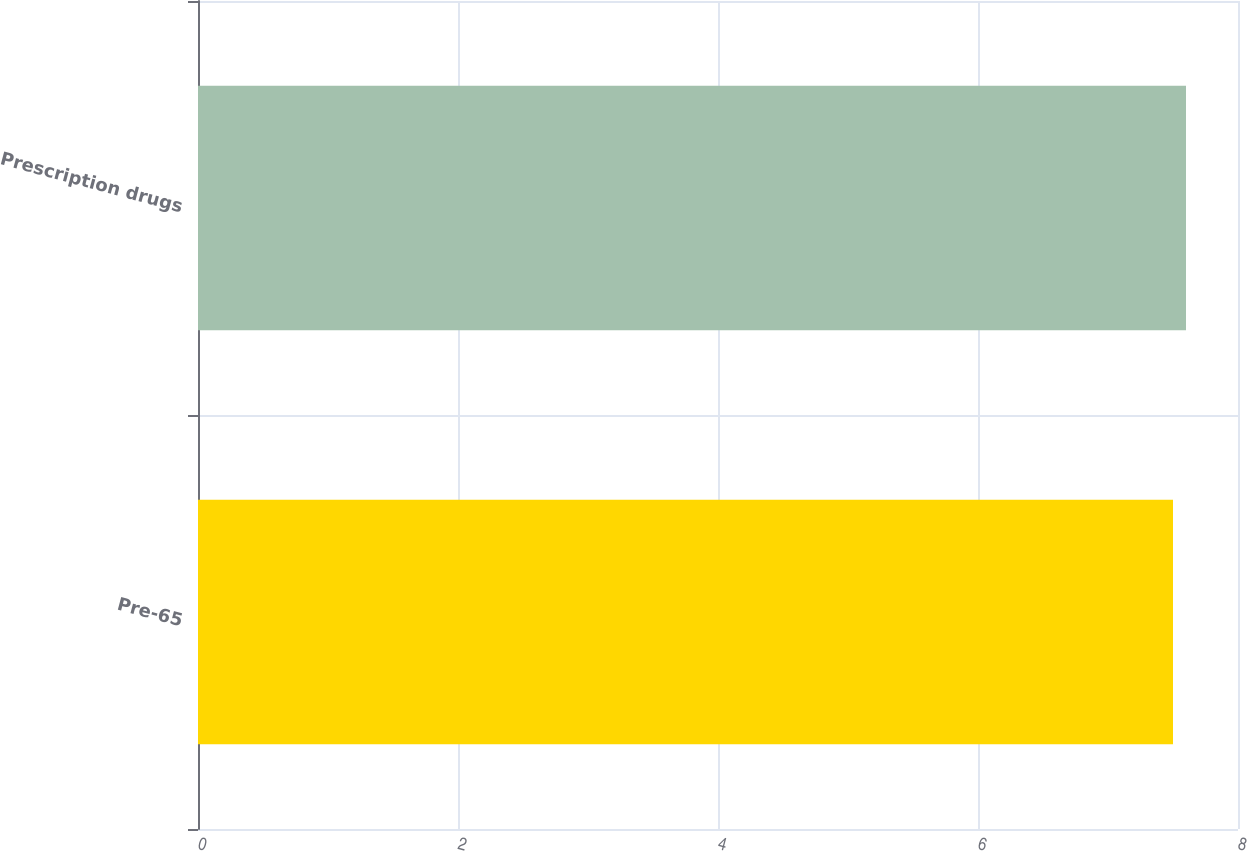<chart> <loc_0><loc_0><loc_500><loc_500><bar_chart><fcel>Pre-65<fcel>Prescription drugs<nl><fcel>7.5<fcel>7.6<nl></chart> 